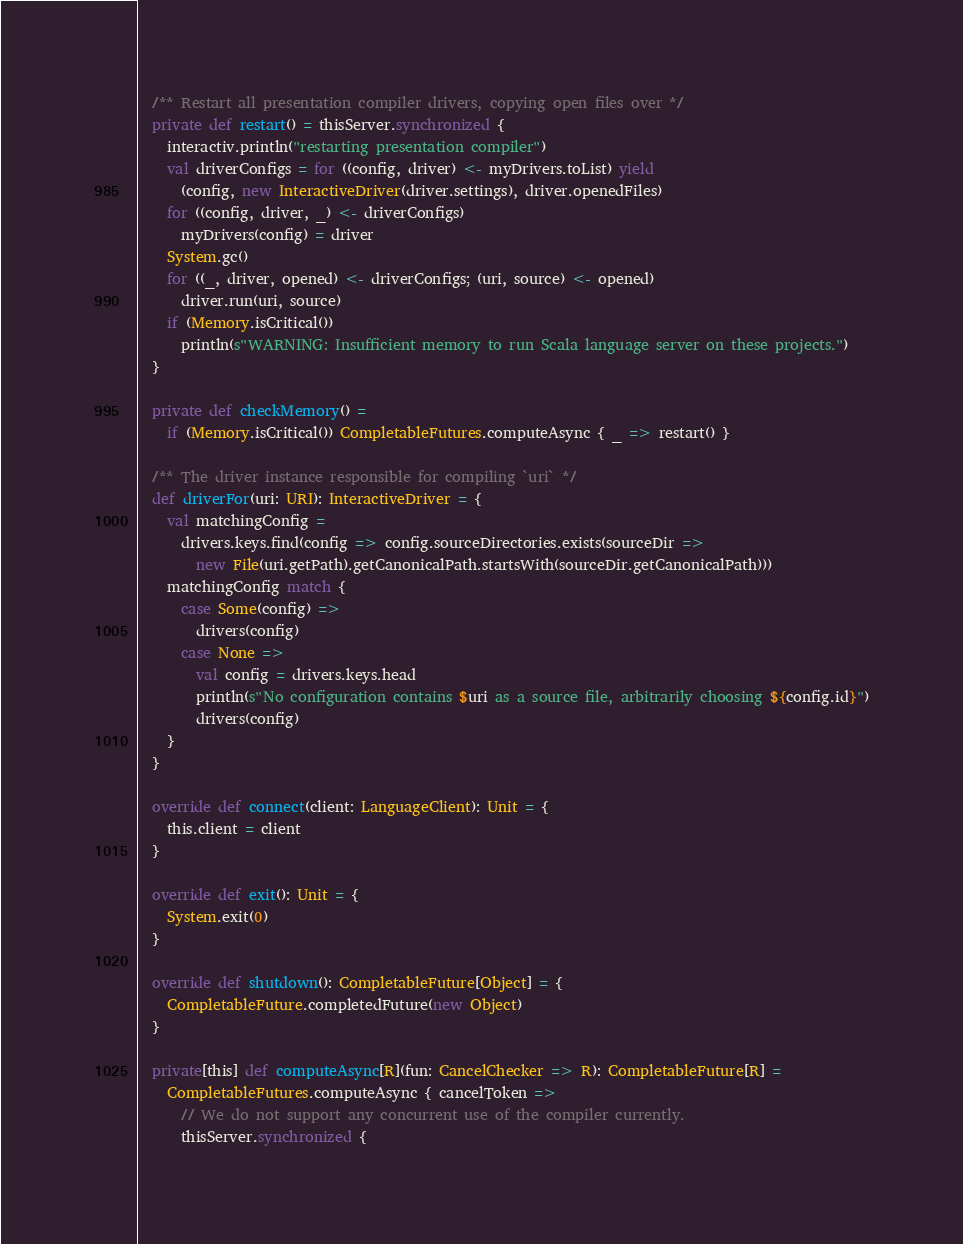<code> <loc_0><loc_0><loc_500><loc_500><_Scala_>
  /** Restart all presentation compiler drivers, copying open files over */
  private def restart() = thisServer.synchronized {
    interactiv.println("restarting presentation compiler")
    val driverConfigs = for ((config, driver) <- myDrivers.toList) yield
      (config, new InteractiveDriver(driver.settings), driver.openedFiles)
    for ((config, driver, _) <- driverConfigs)
      myDrivers(config) = driver
    System.gc()
    for ((_, driver, opened) <- driverConfigs; (uri, source) <- opened)
      driver.run(uri, source)
    if (Memory.isCritical())
      println(s"WARNING: Insufficient memory to run Scala language server on these projects.")
  }

  private def checkMemory() =
    if (Memory.isCritical()) CompletableFutures.computeAsync { _ => restart() }

  /** The driver instance responsible for compiling `uri` */
  def driverFor(uri: URI): InteractiveDriver = {
    val matchingConfig =
      drivers.keys.find(config => config.sourceDirectories.exists(sourceDir =>
        new File(uri.getPath).getCanonicalPath.startsWith(sourceDir.getCanonicalPath)))
    matchingConfig match {
      case Some(config) =>
        drivers(config)
      case None =>
        val config = drivers.keys.head
        println(s"No configuration contains $uri as a source file, arbitrarily choosing ${config.id}")
        drivers(config)
    }
  }

  override def connect(client: LanguageClient): Unit = {
    this.client = client
  }

  override def exit(): Unit = {
    System.exit(0)
  }

  override def shutdown(): CompletableFuture[Object] = {
    CompletableFuture.completedFuture(new Object)
  }

  private[this] def computeAsync[R](fun: CancelChecker => R): CompletableFuture[R] =
    CompletableFutures.computeAsync { cancelToken =>
      // We do not support any concurrent use of the compiler currently.
      thisServer.synchronized {</code> 